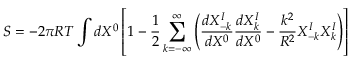<formula> <loc_0><loc_0><loc_500><loc_500>S = - 2 \pi R T \int d X ^ { 0 } \left [ 1 - { \frac { 1 } { 2 } } \sum _ { k = - \infty } ^ { \infty } \left ( { \frac { d X _ { - k } ^ { I } } { d X ^ { 0 } } } { \frac { d X _ { k } ^ { I } } { d X ^ { 0 } } } - { \frac { k ^ { 2 } } { R ^ { 2 } } } X _ { - k } ^ { I } X _ { k } ^ { I } \right ) \right ]</formula> 